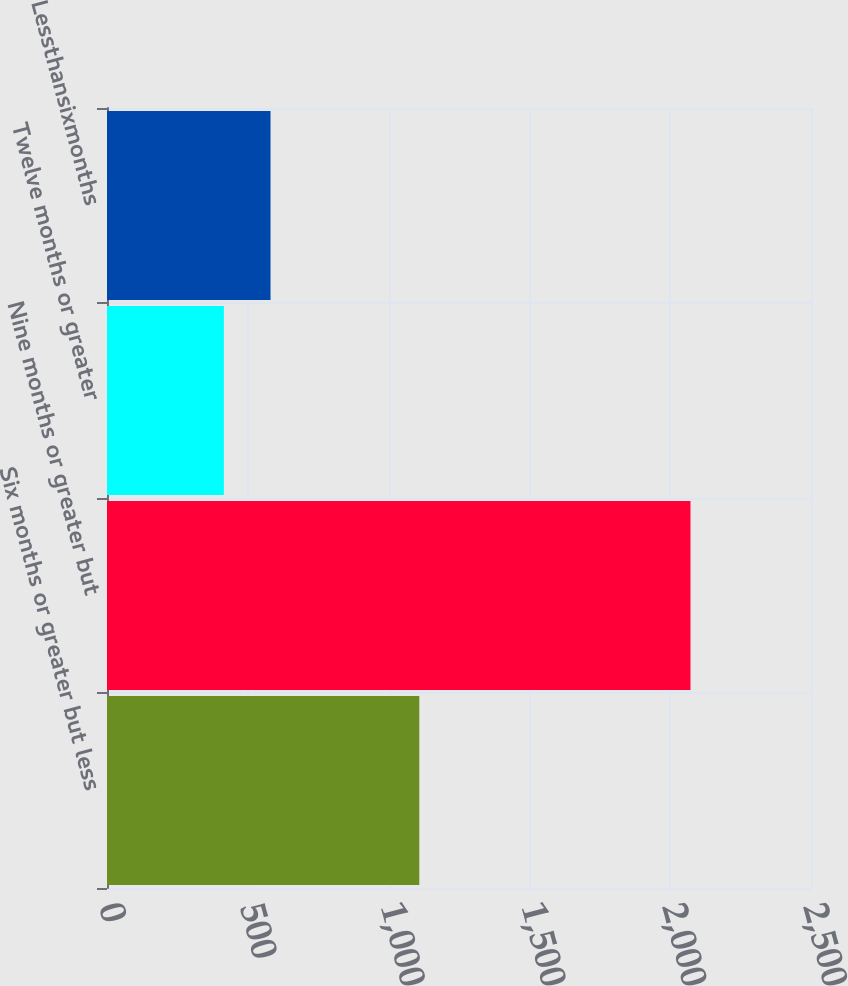Convert chart to OTSL. <chart><loc_0><loc_0><loc_500><loc_500><bar_chart><fcel>Six months or greater but less<fcel>Nine months or greater but<fcel>Twelve months or greater<fcel>Lessthansixmonths<nl><fcel>1109<fcel>2072<fcel>415<fcel>580.7<nl></chart> 